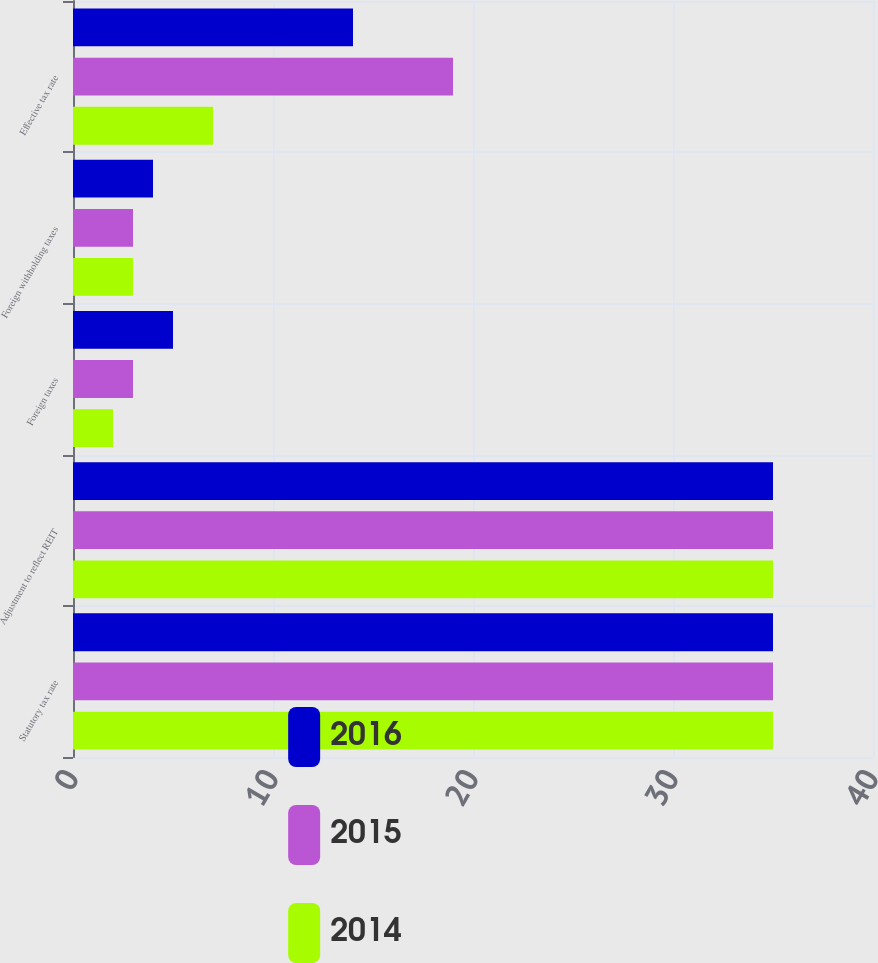<chart> <loc_0><loc_0><loc_500><loc_500><stacked_bar_chart><ecel><fcel>Statutory tax rate<fcel>Adjustment to reflect REIT<fcel>Foreign taxes<fcel>Foreign withholding taxes<fcel>Effective tax rate<nl><fcel>2016<fcel>35<fcel>35<fcel>5<fcel>4<fcel>14<nl><fcel>2015<fcel>35<fcel>35<fcel>3<fcel>3<fcel>19<nl><fcel>2014<fcel>35<fcel>35<fcel>2<fcel>3<fcel>7<nl></chart> 